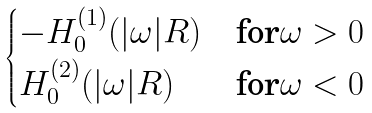Convert formula to latex. <formula><loc_0><loc_0><loc_500><loc_500>\begin{cases} - H _ { 0 } ^ { ( 1 ) } ( | \omega | R ) & \text {for} \omega > 0 \\ H _ { 0 } ^ { ( 2 ) } ( | \omega | R ) & \text {for} \omega < 0 \end{cases}</formula> 